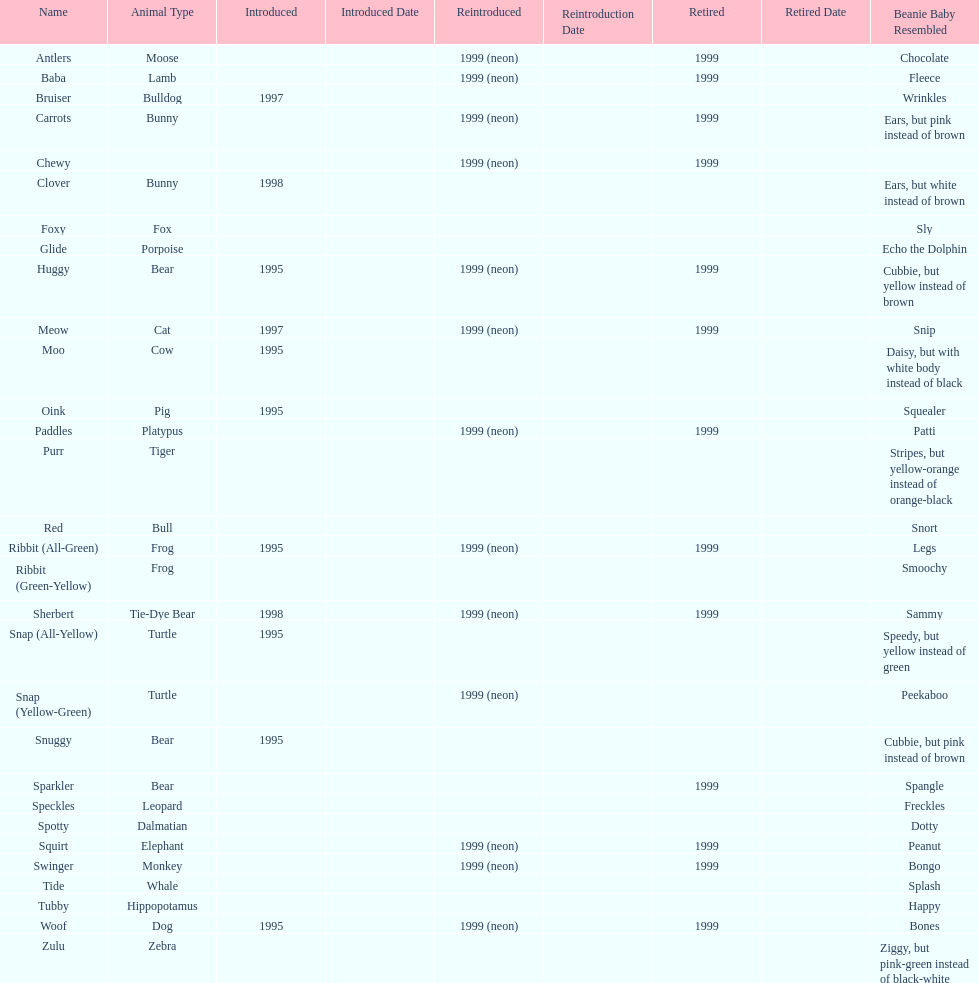What is the name of the pillow pal listed after clover? Foxy. 